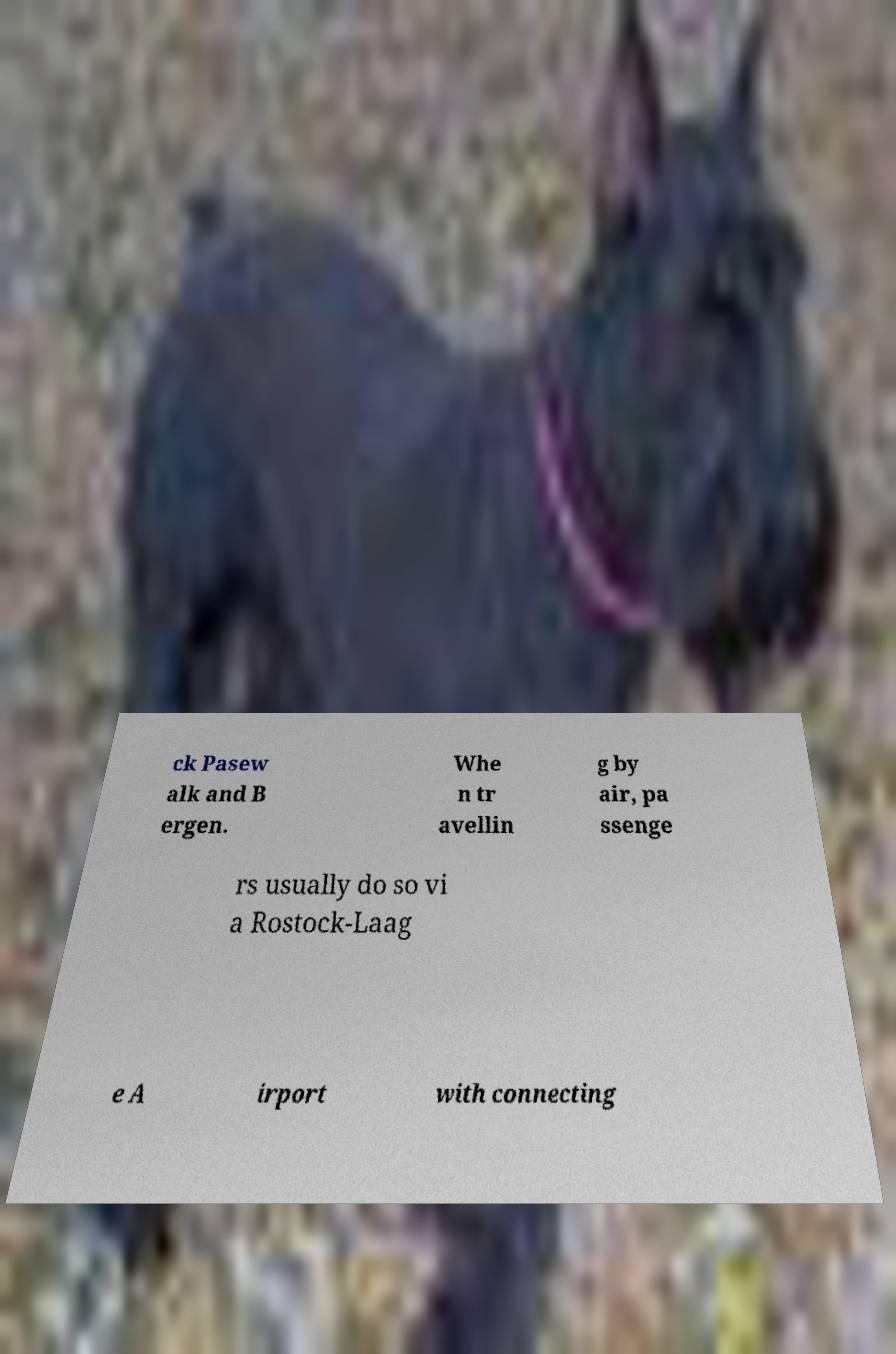Can you read and provide the text displayed in the image?This photo seems to have some interesting text. Can you extract and type it out for me? ck Pasew alk and B ergen. Whe n tr avellin g by air, pa ssenge rs usually do so vi a Rostock-Laag e A irport with connecting 